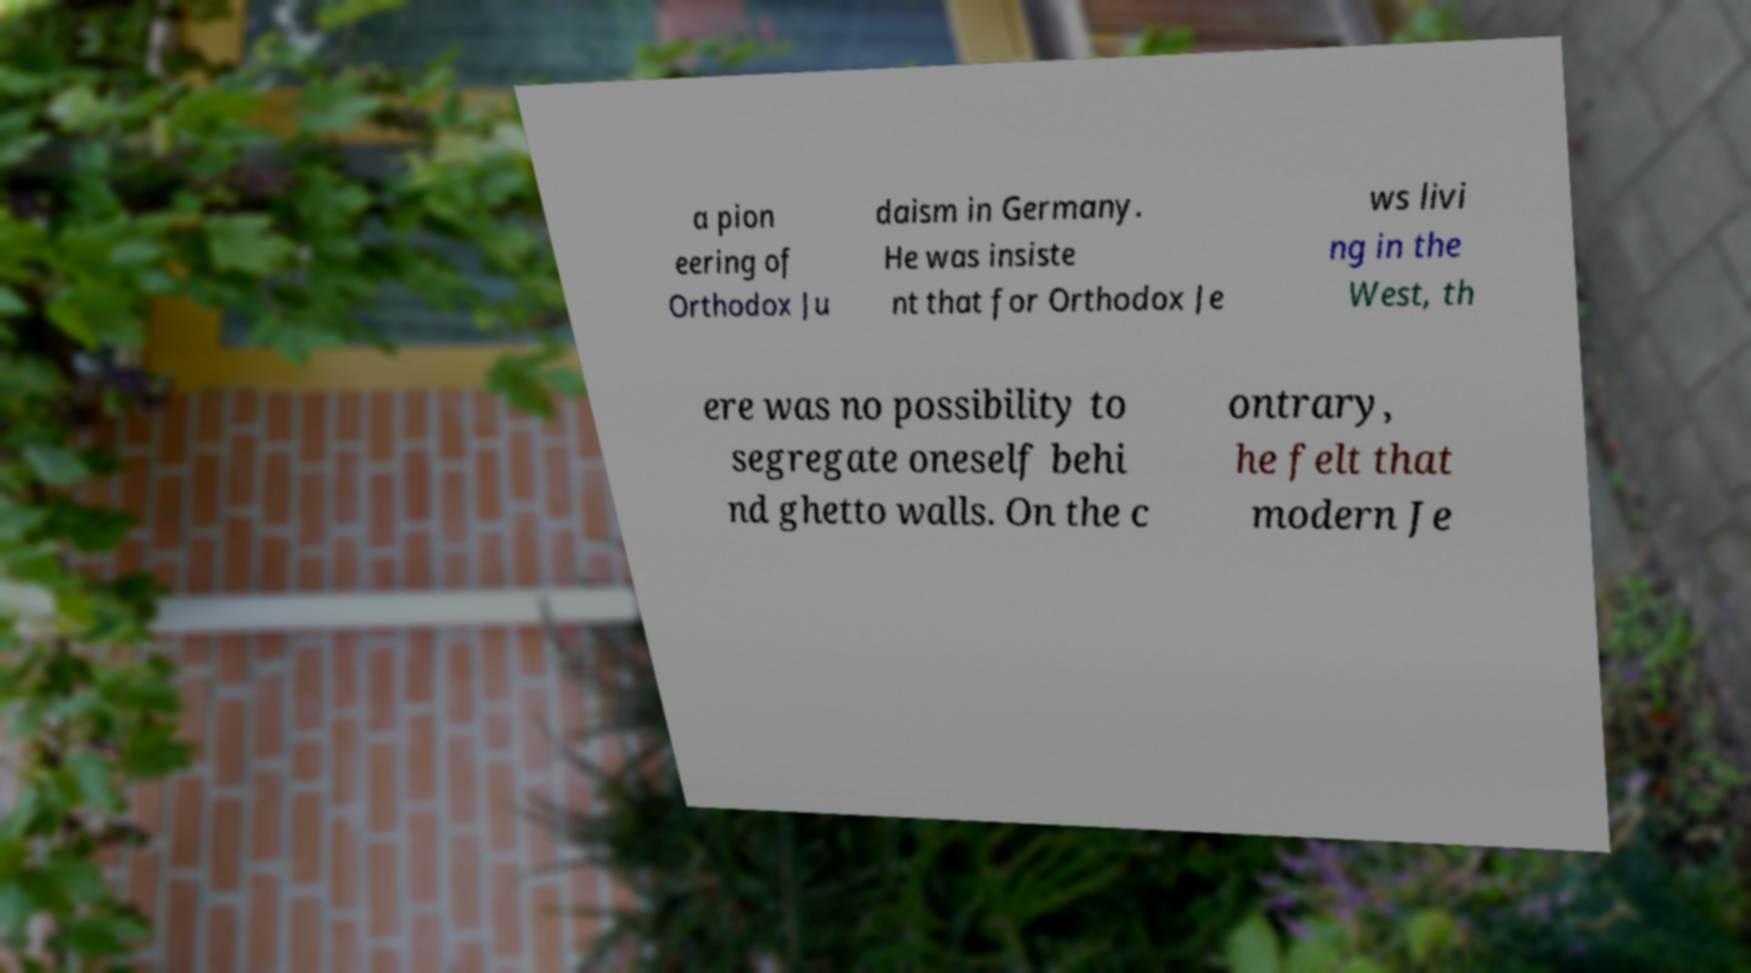I need the written content from this picture converted into text. Can you do that? a pion eering of Orthodox Ju daism in Germany. He was insiste nt that for Orthodox Je ws livi ng in the West, th ere was no possibility to segregate oneself behi nd ghetto walls. On the c ontrary, he felt that modern Je 